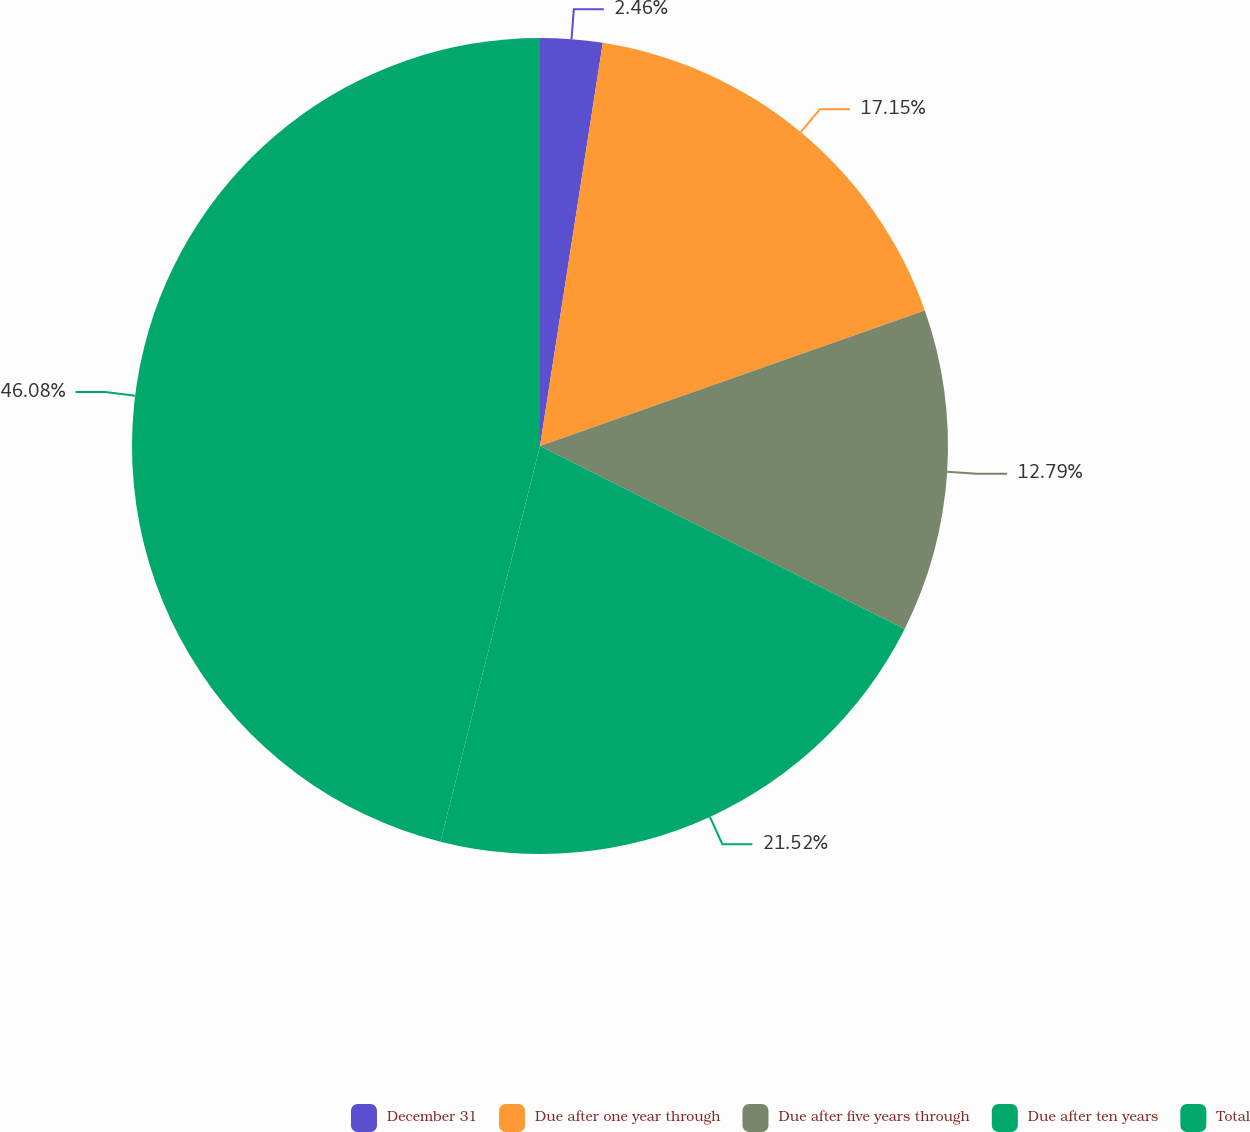<chart> <loc_0><loc_0><loc_500><loc_500><pie_chart><fcel>December 31<fcel>Due after one year through<fcel>Due after five years through<fcel>Due after ten years<fcel>Total<nl><fcel>2.46%<fcel>17.15%<fcel>12.79%<fcel>21.52%<fcel>46.07%<nl></chart> 